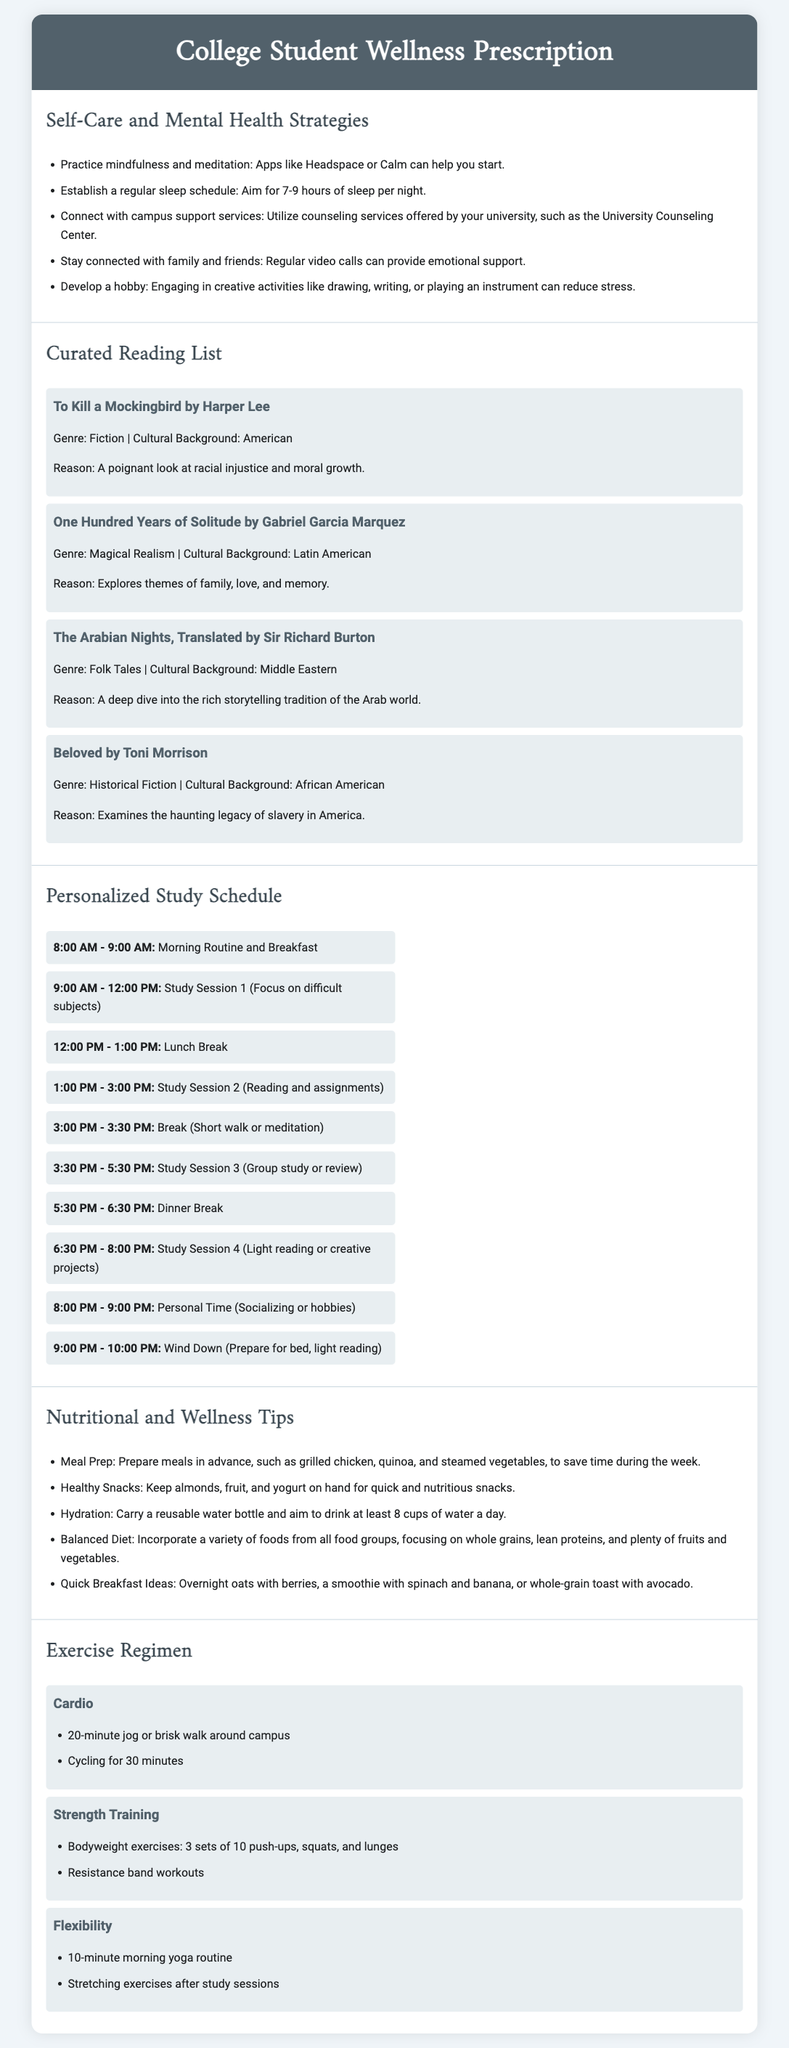What is the title of the document? The title is presented in the header section of the document, which is "College Student Wellness Prescription."
Answer: College Student Wellness Prescription How many books are listed in the curated reading list? The curated reading list section contains four books highlighted with their details.
Answer: 4 What is the first recommended strategy for self-care? The first strategy in the self-care section is to practice mindfulness and meditation using apps.
Answer: Practice mindfulness and meditation What time is allocated for the first study session? The personalized study schedule indicates that the first study session is from 9:00 AM to 12:00 PM.
Answer: 9:00 AM - 12:00 PM Which exercise is suggested for flexibility? The exercise regimen recommends a 10-minute morning yoga routine as a flexibility exercise.
Answer: 10-minute morning yoga routine What is one quick breakfast idea mentioned? Among the suggestions for quick breakfast ideas, overnight oats with berries is specified.
Answer: Overnight oats with berries What type of training is included in the exercise regimen besides cardio? The exercise regimen includes strength training as a second type of training.
Answer: Strength training What is the recommended daily water intake? The nutritional tips section suggests a daily water intake of at least 8 cups.
Answer: 8 cups 